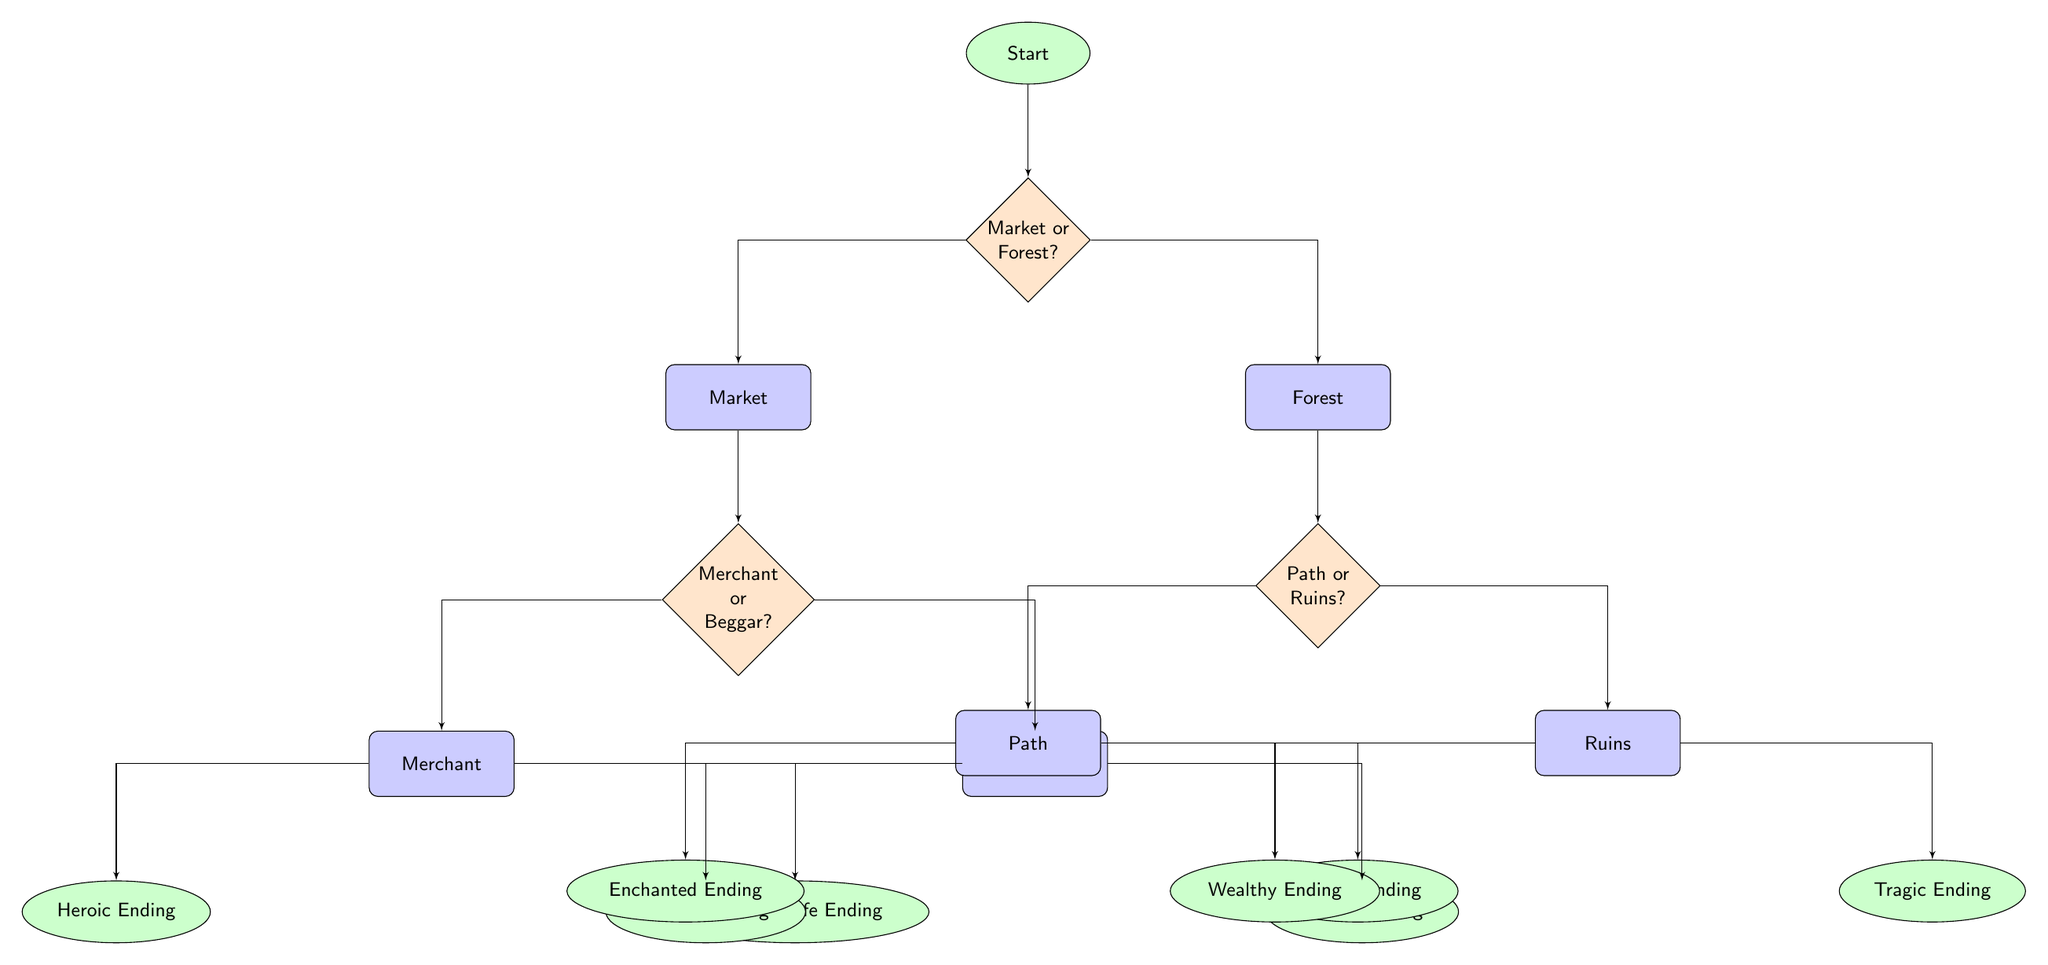What is the starting point of the diagram? The starting point is represented by the cloud labeled "Start". This node serves as the entry to the branching paths of the visual novel.
Answer: Start How many main decision points are there in the diagram? The diagram contains three main decision points: "Market or Forest?", "Merchant or Beggar?", and "Path or Ruins?". Counting these gives a total of three.
Answer: 3 What are the two options after the first decision point? The first decision point leads to two options: "Market" and "Forest". These are the immediate choices for the player after starting the game.
Answer: Market, Forest Which ending is associated with the "Merchant" choice? The "Merchant" choice leads to two potential endings: "Heroic Ending" and "Ordinary Life Ending". The player who chooses "Merchant" will ultimately reach one of these endings.
Answer: Heroic Ending, Ordinary Life Ending What is the path leading to the "Warrior Ending"? To reach the "Warrior Ending", the player must first choose "Forest" as the initial path, then select "Path" in the subsequent decision point. This is a linear flow of decisions resulting in that ending.
Answer: Forest, Path What are the consequences of choosing "Beggar" in the game? Choosing "Beggar" leads to two distinct outcomes: "Blessed Ending" and "Cursed Ending", which represent the results of this particular choice.
Answer: Blessed Ending, Cursed Ending What is the total number of endings available in this game? There are a total of six endings available. They are: "Heroic Ending", "Ordinary Life Ending", "Blessed Ending", "Cursed Ending", "Enchanted Ending", "Warrior Ending", "Wealthy Ending", and "Tragic Ending". Counting these gives eight distinct endings.
Answer: 8 If the player takes the "Ruins" path, what are the two possible outcomes? Taking the "Ruins" path leads to two possible outcomes: "Wealthy Ending" and "Tragic Ending". This gives the player two directions to consider after selecting "Ruins".
Answer: Wealthy Ending, Tragic Ending What is the relationship between "Market" and "Merchant"? "Merchant" is a subsequent decision point that arises after first choosing "Market". It indicates that "Merchant" is a further choice based on the initial selection of "Market".
Answer: Subsequent choice 